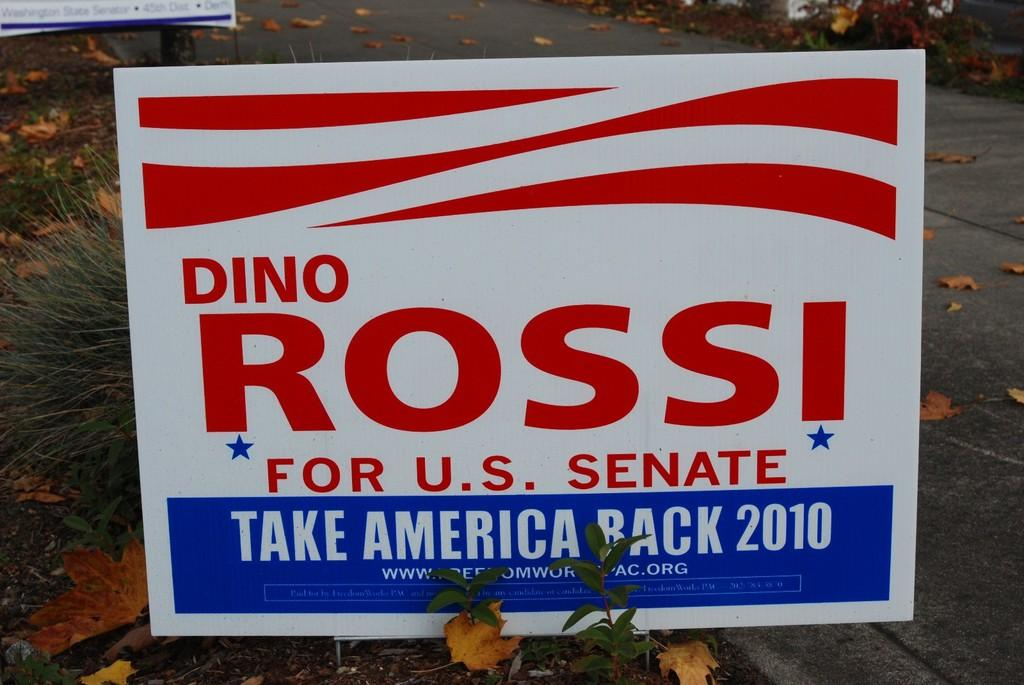What is written or displayed on the board in the image? There is a board with text in the image. What type of vegetation is on the left side of the image? There is grass on the left side of the image. What can be seen in the background of the image? There is a road and leaves visible in the background of the image. What type of copper art can be seen in the image? There is no copper art present in the image. What kind of pet is visible in the image? There is no pet visible in the image. 